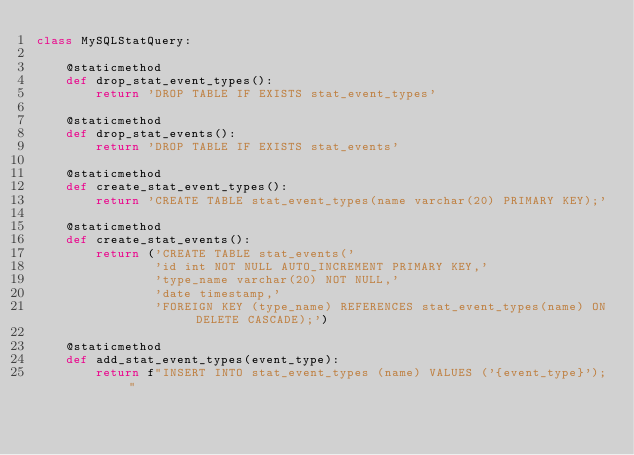<code> <loc_0><loc_0><loc_500><loc_500><_Python_>class MySQLStatQuery:

    @staticmethod
    def drop_stat_event_types():
        return 'DROP TABLE IF EXISTS stat_event_types'

    @staticmethod
    def drop_stat_events():
        return 'DROP TABLE IF EXISTS stat_events'

    @staticmethod
    def create_stat_event_types():
        return 'CREATE TABLE stat_event_types(name varchar(20) PRIMARY KEY);'

    @staticmethod
    def create_stat_events():
        return ('CREATE TABLE stat_events('
                'id int NOT NULL AUTO_INCREMENT PRIMARY KEY,'
                'type_name varchar(20) NOT NULL,'
                'date timestamp,'
                'FOREIGN KEY (type_name) REFERENCES stat_event_types(name) ON DELETE CASCADE);')

    @staticmethod
    def add_stat_event_types(event_type):
        return f"INSERT INTO stat_event_types (name) VALUES ('{event_type}');"
</code> 